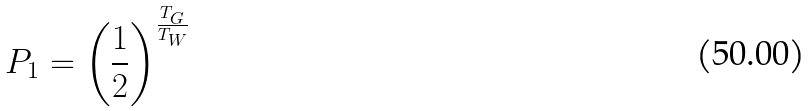<formula> <loc_0><loc_0><loc_500><loc_500>P _ { 1 } = \left ( \frac { 1 } { 2 } \right ) ^ { \frac { T _ { G } } { T _ { W } } }</formula> 